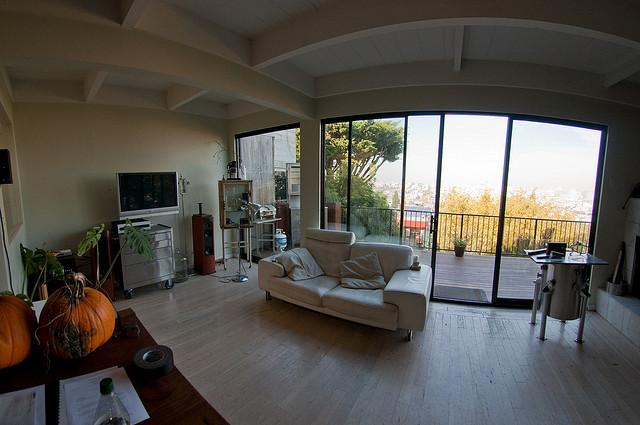How many pumpkins do you see?
Answer briefly. 2. How many people does that loveseat hold?
Keep it brief. 2. Where are the pumpkins located?
Give a very brief answer. Table. Do the colors of the pillows match the rug?
Concise answer only. No. 